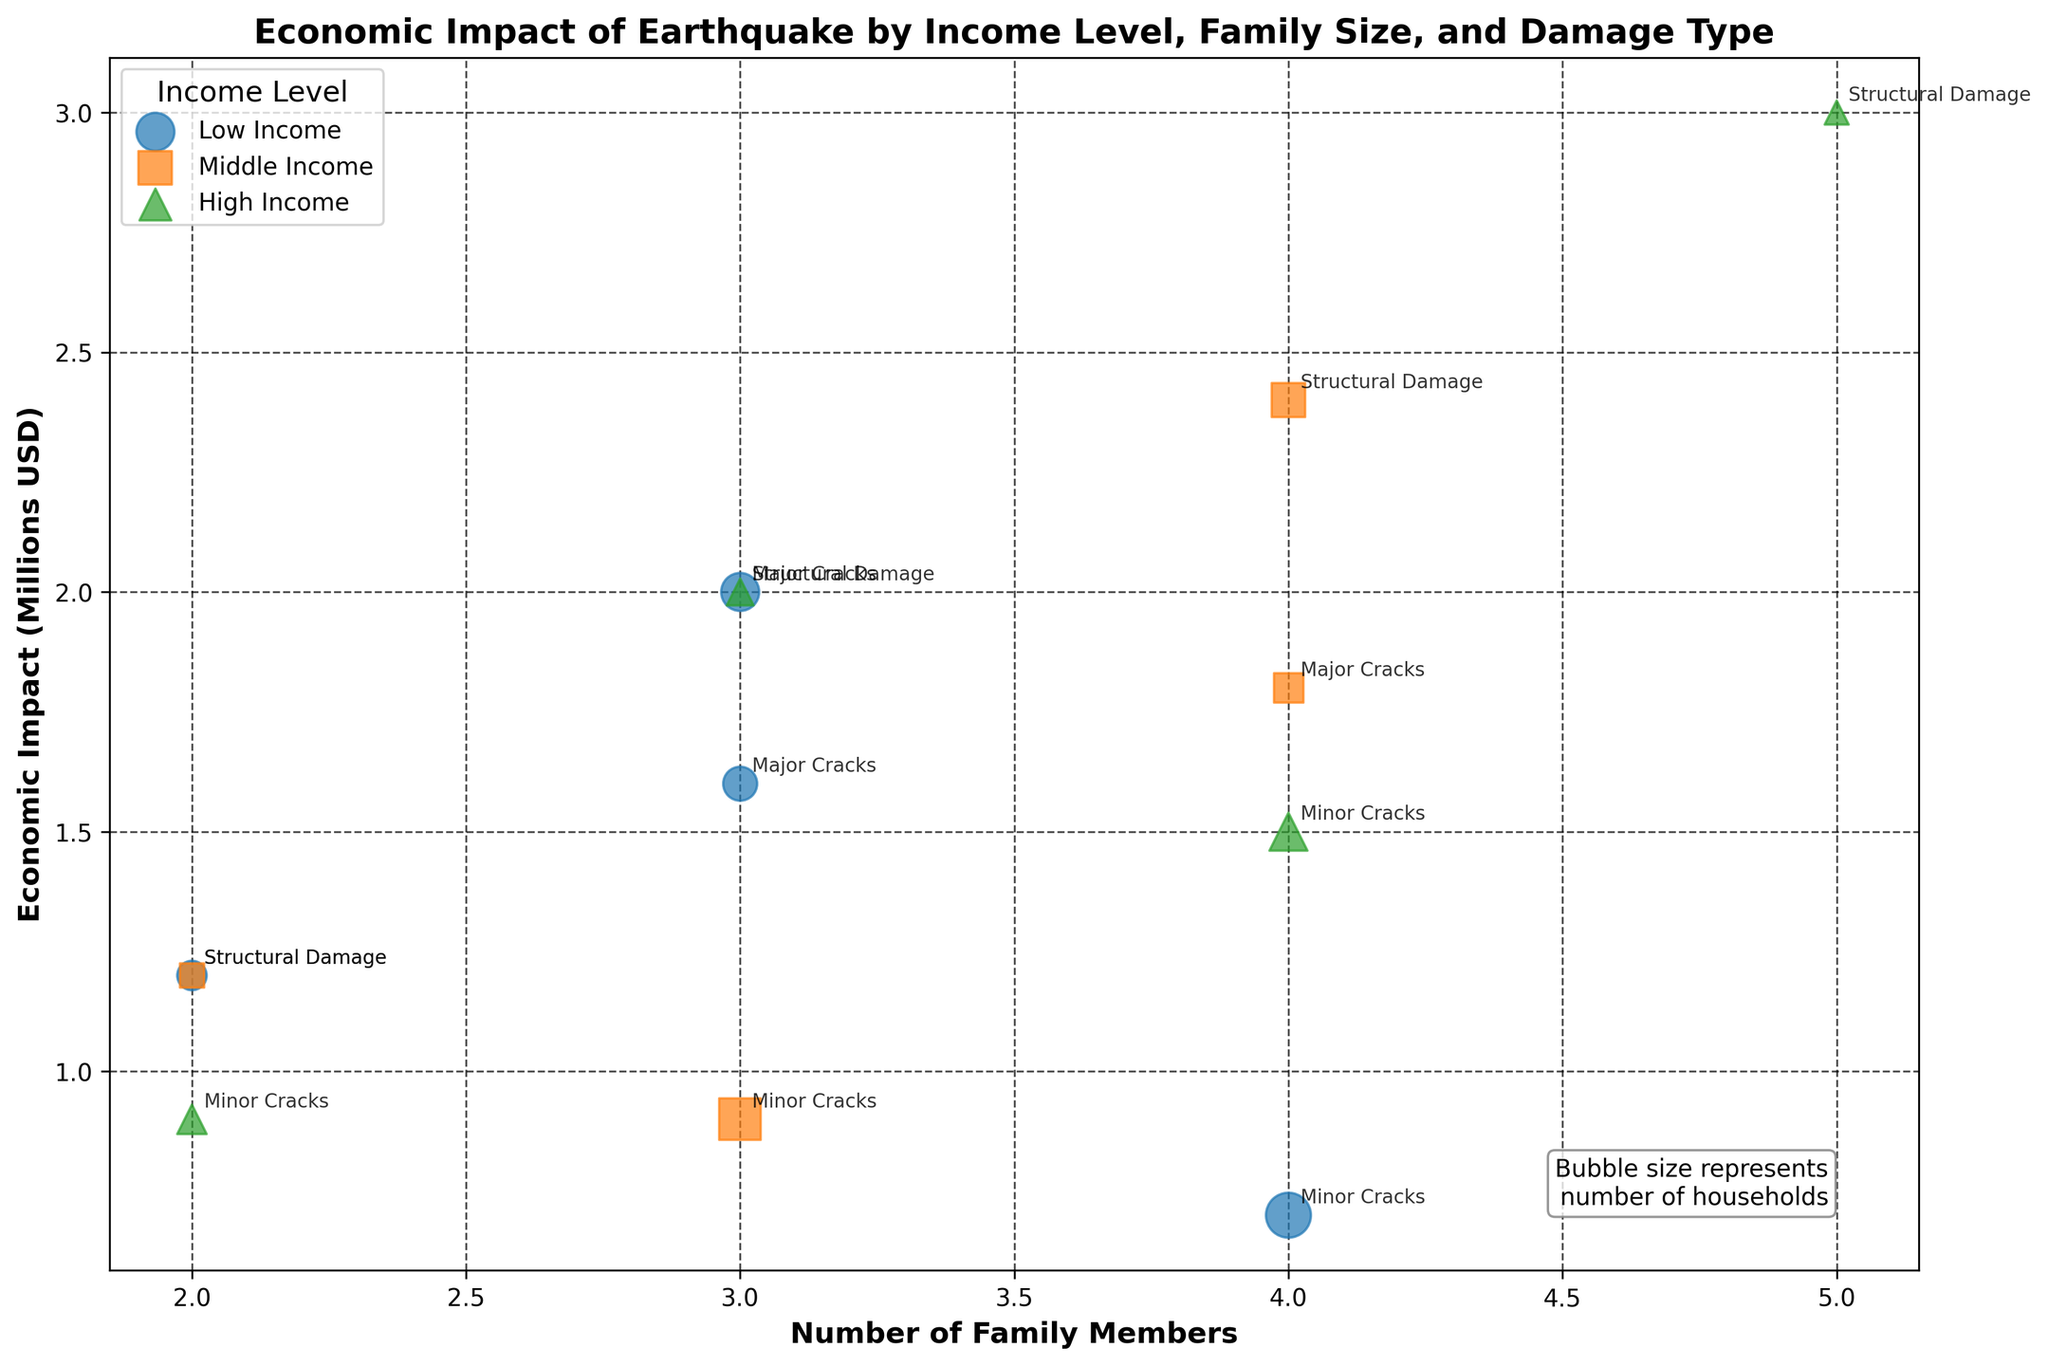How many unique income levels are represented in the chart? The chart uses different colors and markers to represent different income levels. By looking at the legend, we can see three categories: Low, Middle, and High Income.
Answer: 3 Which income level has the highest economic impact for households with four family members and structural damage? According to the annotations on the plot, the highest economic impact for households with four family members and structural damage comes from the Middle-income group. This can be determined by comparing the y-axis values for the relevant data points.
Answer: Middle What type of property damage is associated with the lowest economic impact in the chart? The type of property damage with the lowest economic impact is identified by locating the bubble with the lowest position on the y-axis. Minor Cracks in the Low-income group have an economic impact of 0.7 million USD.
Answer: Minor Cracks How does the economic impact of major cracks for High-income families compare to that for Low-income families? For High-income families, major cracks have an economic impact of 2 million USD. For Low-income families, the economic impact of major cracks is 1.6 million USD. By comparing these values, we see that the impact is greater for High-income families.
Answer: Higher for High-income families What is the size of the bubble representing low-income families with three members and structural damage? The size of the bubble is proportional to the number of households. For low-income families with three members and structural damage, there are 50 households. The chart multiplies the number by 5 for visibility, so the bubble size represents 250 units.
Answer: 250 units What is the total economic impact for households with two family members across all income levels? Sum the economic impact for all income levels with two family members. For Low-income: 1.2M; for Middle-income: 1.2M; for High-income: 0.9M. The total is 1.2 + 1.2 + 0.9 = 3.3 million USD.
Answer: 3.3 million USD Which type of property damage has the highest frequency for High-income households? The size of each bubble points to the number of households. The bubble for Minor Cracks in High-income households with four members is the largest, suggesting the highest frequency for property damage.
Answer: Minor Cracks Is the economic impact generally higher for households with more members regardless of income level? By comparing bubbles across the chart, we generally see that bubbles representing households with more family members are positioned higher on the y-axis, indicating a higher economic impact.
Answer: Yes What is the difference in economic impact between structural damage for Middle-income families with two members and Major cracks for the same group with four members? For Middle-income families, structural damage for two members is 1.2M, and major cracks for four members is 1.8M. The difference is 1.8 - 1.2 = 0.6 million USD.
Answer: 0.6 million USD How does the number of households with structural damage compare between Low and Middle-income groups? The size of the bubbles indicates the number of households. Low-income has 50 (3 members) + 30 (2 members) = 80 households. Middle-income has 40 (4 members) + 20 (2 members) = 60 households. Therefore, Low-income families have more households with structural damage.
Answer: More in Low-income 